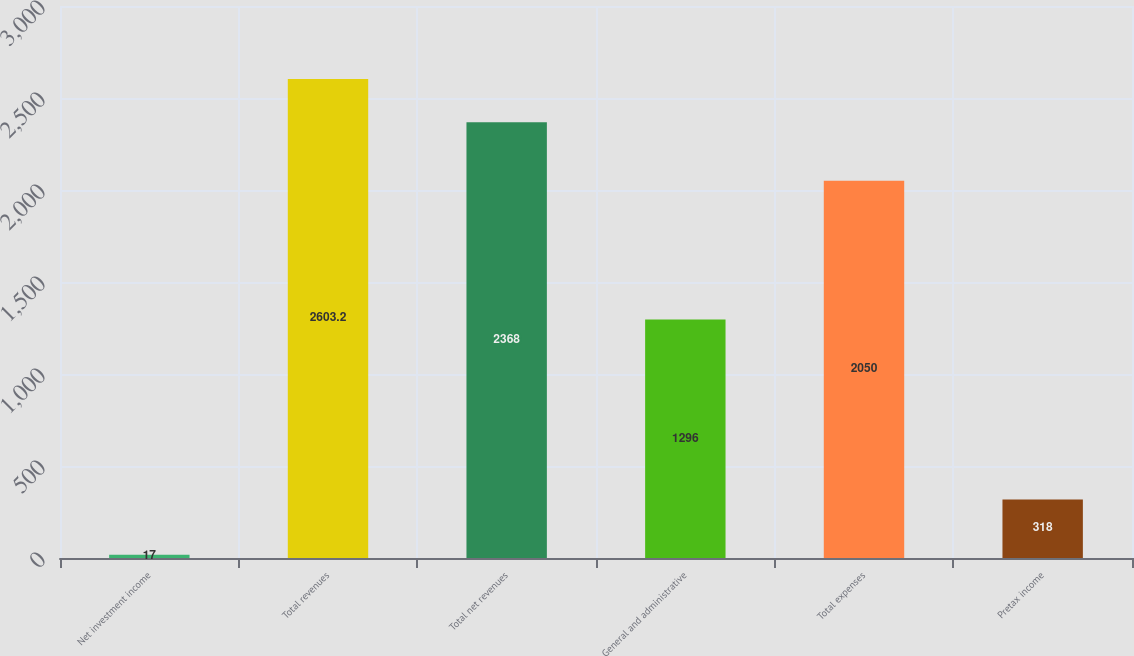Convert chart to OTSL. <chart><loc_0><loc_0><loc_500><loc_500><bar_chart><fcel>Net investment income<fcel>Total revenues<fcel>Total net revenues<fcel>General and administrative<fcel>Total expenses<fcel>Pretax income<nl><fcel>17<fcel>2603.2<fcel>2368<fcel>1296<fcel>2050<fcel>318<nl></chart> 